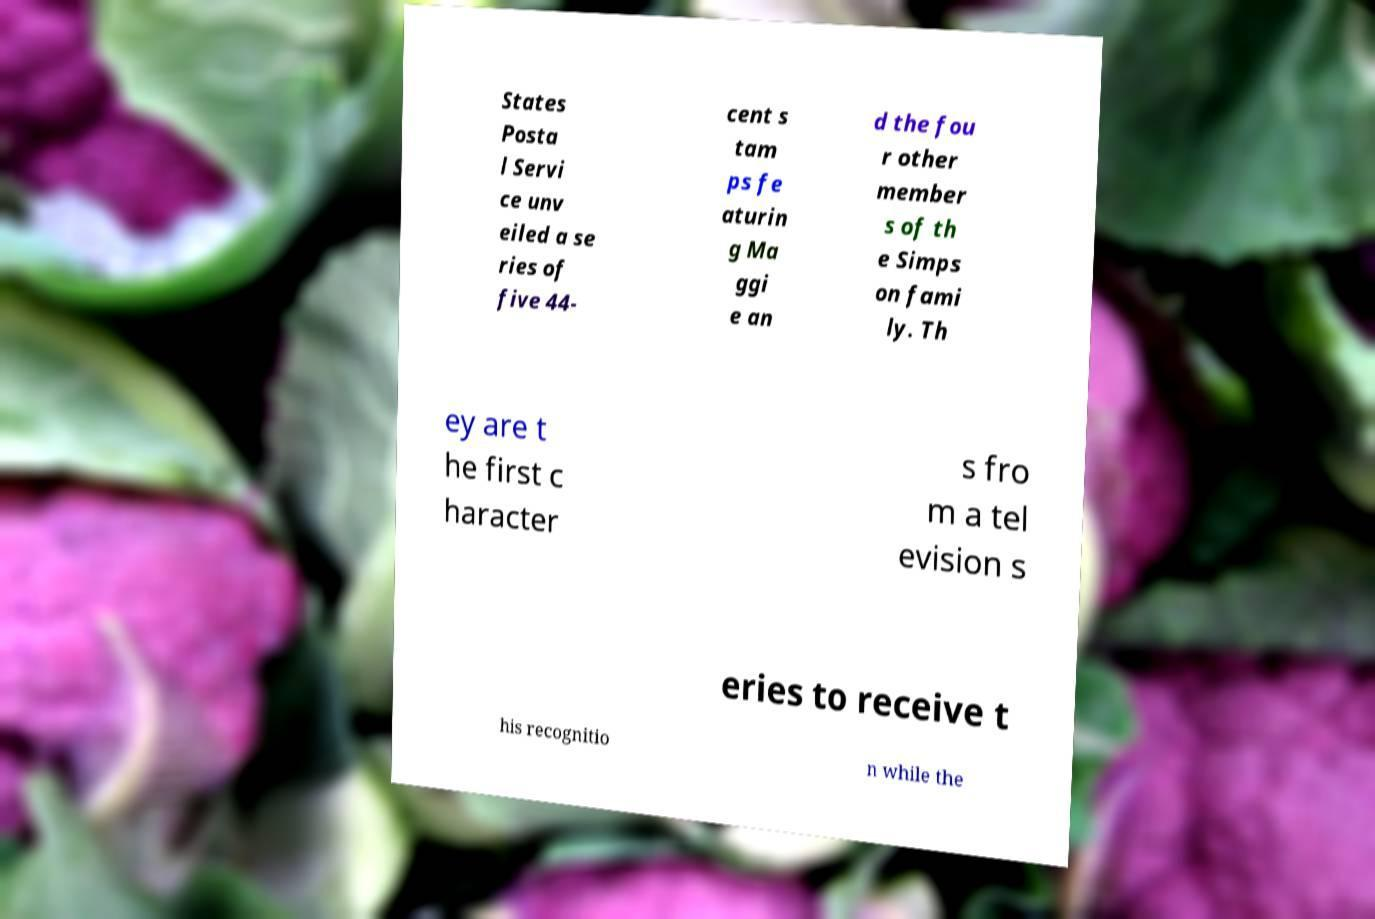Please identify and transcribe the text found in this image. States Posta l Servi ce unv eiled a se ries of five 44- cent s tam ps fe aturin g Ma ggi e an d the fou r other member s of th e Simps on fami ly. Th ey are t he first c haracter s fro m a tel evision s eries to receive t his recognitio n while the 